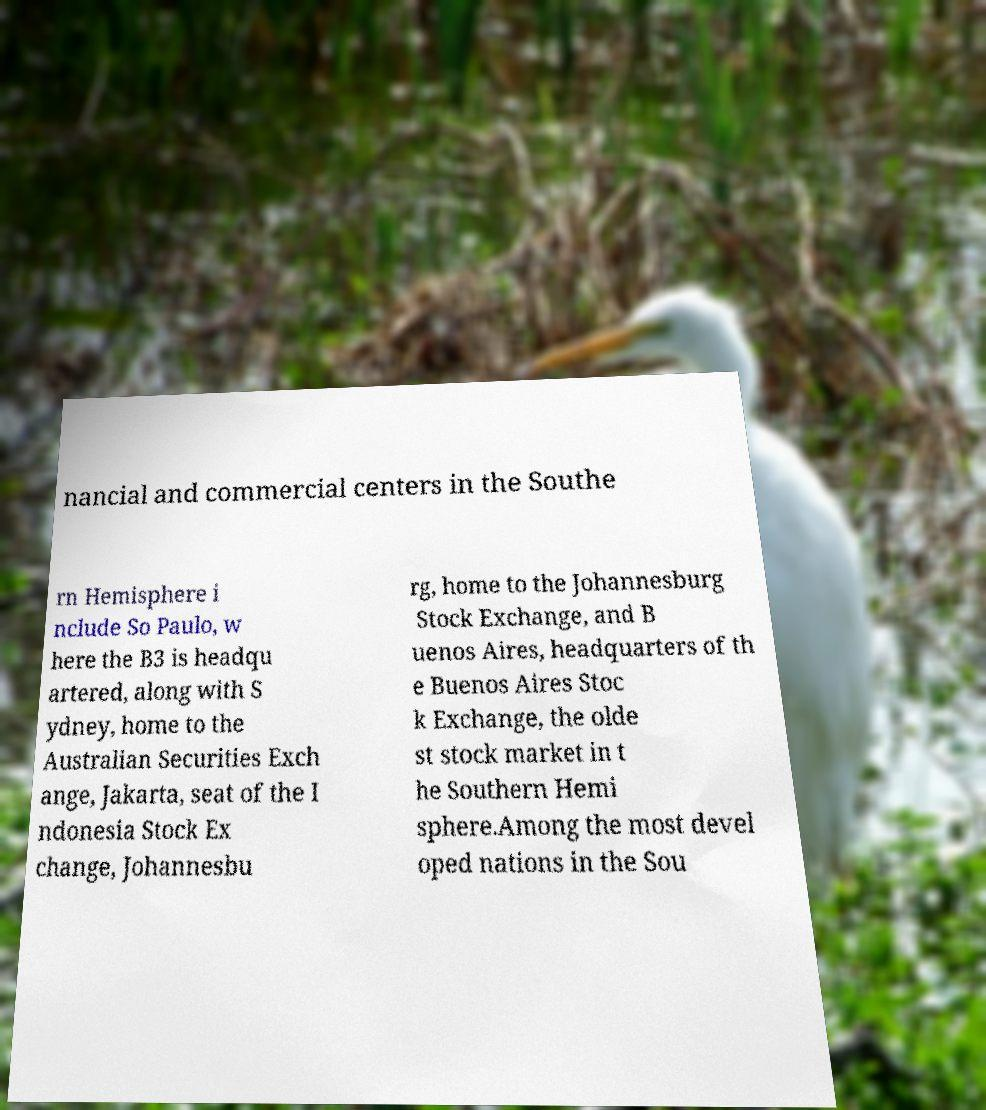Could you assist in decoding the text presented in this image and type it out clearly? nancial and commercial centers in the Southe rn Hemisphere i nclude So Paulo, w here the B3 is headqu artered, along with S ydney, home to the Australian Securities Exch ange, Jakarta, seat of the I ndonesia Stock Ex change, Johannesbu rg, home to the Johannesburg Stock Exchange, and B uenos Aires, headquarters of th e Buenos Aires Stoc k Exchange, the olde st stock market in t he Southern Hemi sphere.Among the most devel oped nations in the Sou 